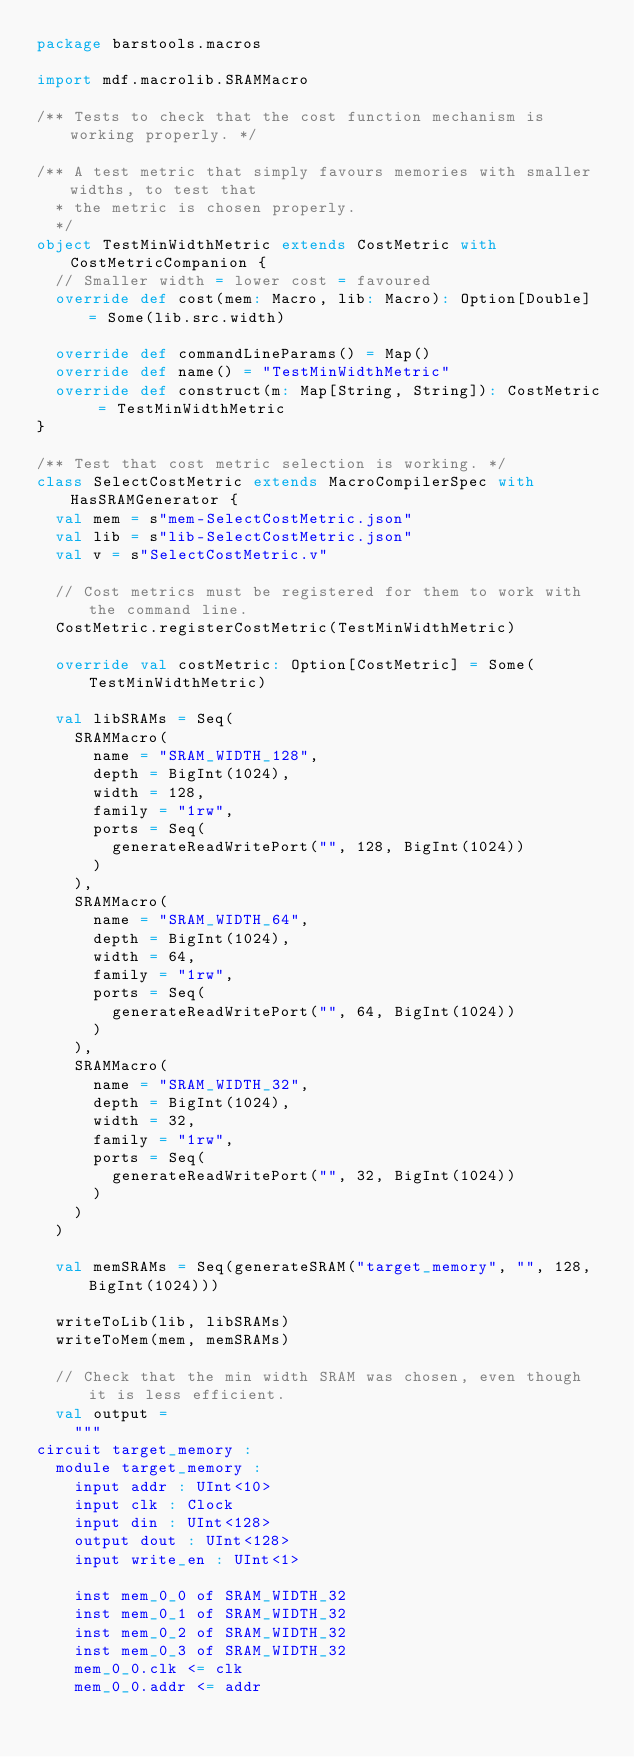<code> <loc_0><loc_0><loc_500><loc_500><_Scala_>package barstools.macros

import mdf.macrolib.SRAMMacro

/** Tests to check that the cost function mechanism is working properly. */

/** A test metric that simply favours memories with smaller widths, to test that
  * the metric is chosen properly.
  */
object TestMinWidthMetric extends CostMetric with CostMetricCompanion {
  // Smaller width = lower cost = favoured
  override def cost(mem: Macro, lib: Macro): Option[Double] = Some(lib.src.width)

  override def commandLineParams() = Map()
  override def name() = "TestMinWidthMetric"
  override def construct(m: Map[String, String]): CostMetric = TestMinWidthMetric
}

/** Test that cost metric selection is working. */
class SelectCostMetric extends MacroCompilerSpec with HasSRAMGenerator {
  val mem = s"mem-SelectCostMetric.json"
  val lib = s"lib-SelectCostMetric.json"
  val v = s"SelectCostMetric.v"

  // Cost metrics must be registered for them to work with the command line.
  CostMetric.registerCostMetric(TestMinWidthMetric)

  override val costMetric: Option[CostMetric] = Some(TestMinWidthMetric)

  val libSRAMs = Seq(
    SRAMMacro(
      name = "SRAM_WIDTH_128",
      depth = BigInt(1024),
      width = 128,
      family = "1rw",
      ports = Seq(
        generateReadWritePort("", 128, BigInt(1024))
      )
    ),
    SRAMMacro(
      name = "SRAM_WIDTH_64",
      depth = BigInt(1024),
      width = 64,
      family = "1rw",
      ports = Seq(
        generateReadWritePort("", 64, BigInt(1024))
      )
    ),
    SRAMMacro(
      name = "SRAM_WIDTH_32",
      depth = BigInt(1024),
      width = 32,
      family = "1rw",
      ports = Seq(
        generateReadWritePort("", 32, BigInt(1024))
      )
    )
  )

  val memSRAMs = Seq(generateSRAM("target_memory", "", 128, BigInt(1024)))

  writeToLib(lib, libSRAMs)
  writeToMem(mem, memSRAMs)

  // Check that the min width SRAM was chosen, even though it is less efficient.
  val output =
    """
circuit target_memory :
  module target_memory :
    input addr : UInt<10>
    input clk : Clock
    input din : UInt<128>
    output dout : UInt<128>
    input write_en : UInt<1>

    inst mem_0_0 of SRAM_WIDTH_32
    inst mem_0_1 of SRAM_WIDTH_32
    inst mem_0_2 of SRAM_WIDTH_32
    inst mem_0_3 of SRAM_WIDTH_32
    mem_0_0.clk <= clk
    mem_0_0.addr <= addr</code> 